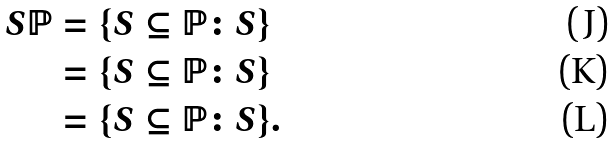Convert formula to latex. <formula><loc_0><loc_0><loc_500><loc_500>S \mathbb { P } & = \{ S \subseteq \mathbb { P } \colon S \} \\ & = \{ S \subseteq \mathbb { P } \colon S \} \\ & = \{ S \subseteq \mathbb { P } \colon S \} .</formula> 